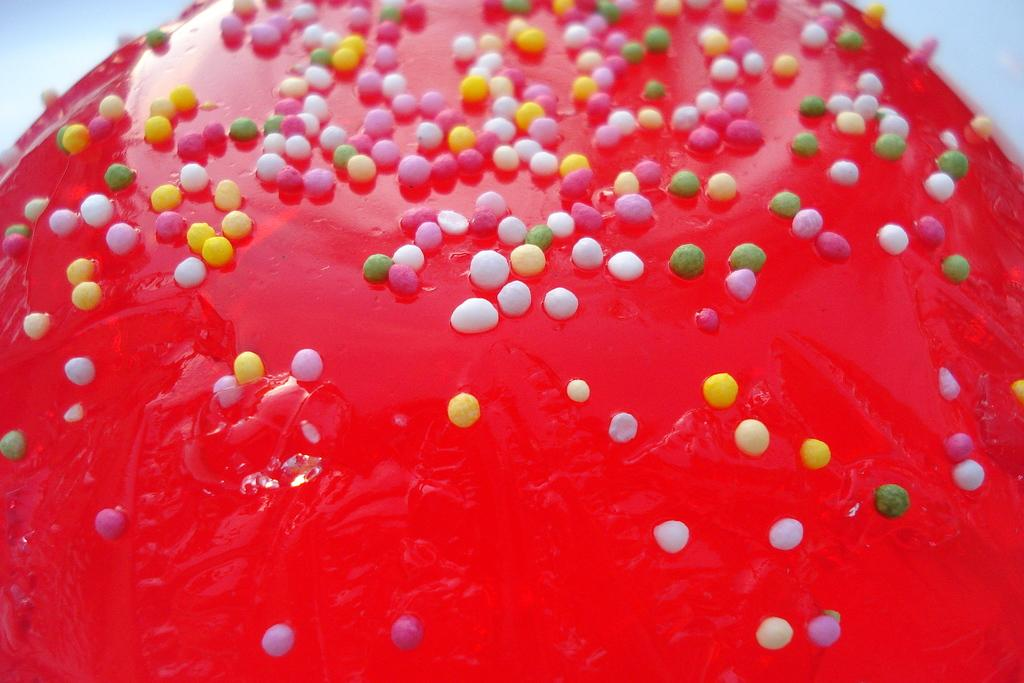What is the color of the candy in the image? The candy in the image is red. What can be seen on the surface of the candy? There are colorful sugar balls on the candy. What type of books can be seen in the image? There are no books present in the image; it features a red color candy with colorful sugar balls. What type of soup is being served in the image? There is no soup present in the image; it features a red color candy with colorful sugar balls. 